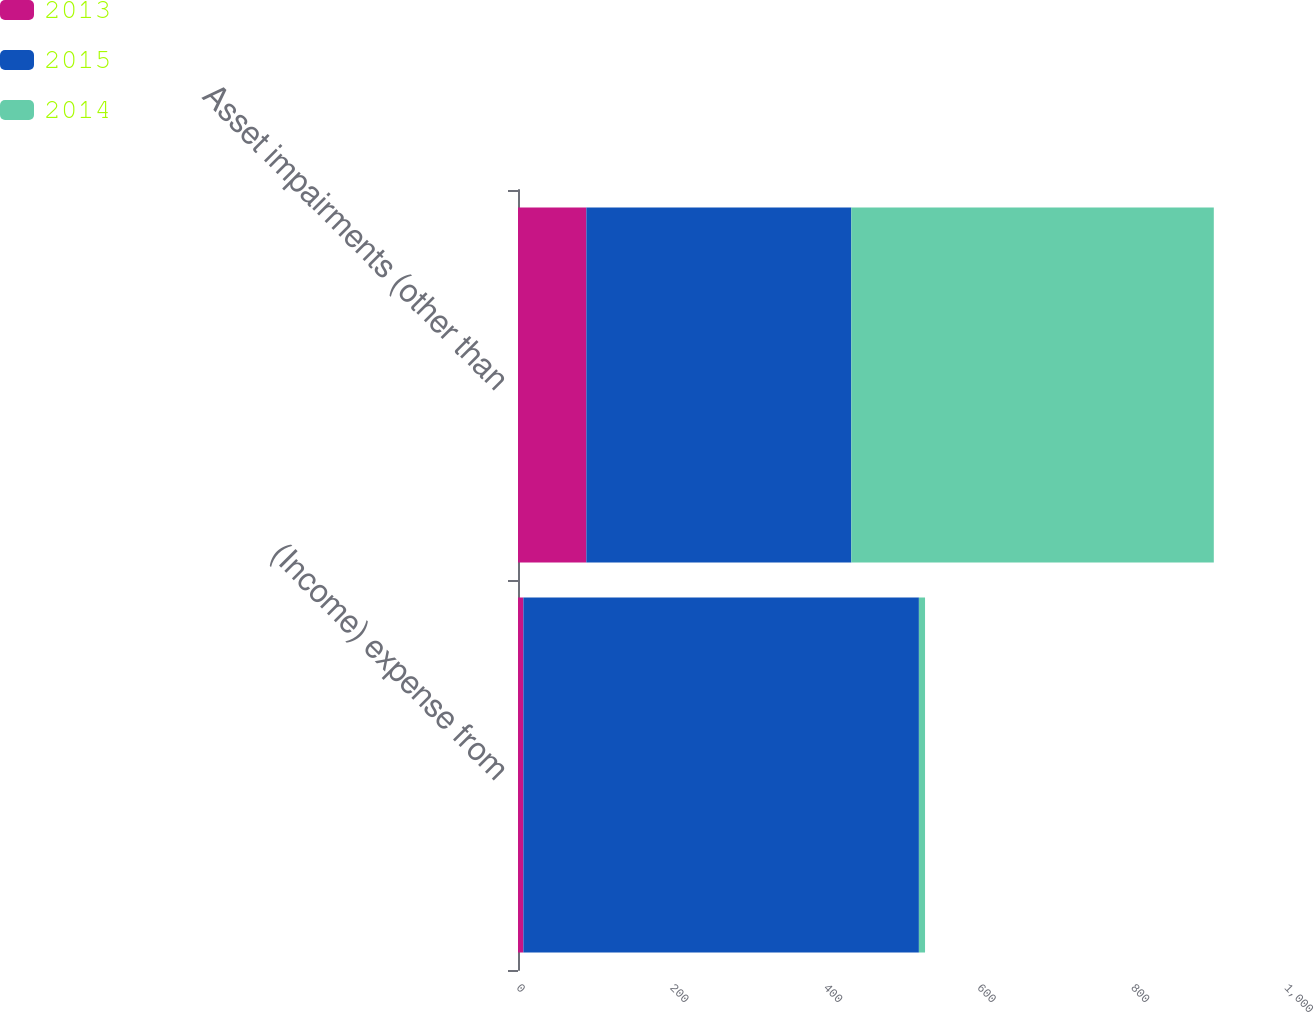Convert chart to OTSL. <chart><loc_0><loc_0><loc_500><loc_500><stacked_bar_chart><ecel><fcel>(Income) expense from<fcel>Asset impairments (other than<nl><fcel>2013<fcel>7<fcel>89<nl><fcel>2015<fcel>515<fcel>345<nl><fcel>2014<fcel>8<fcel>472<nl></chart> 